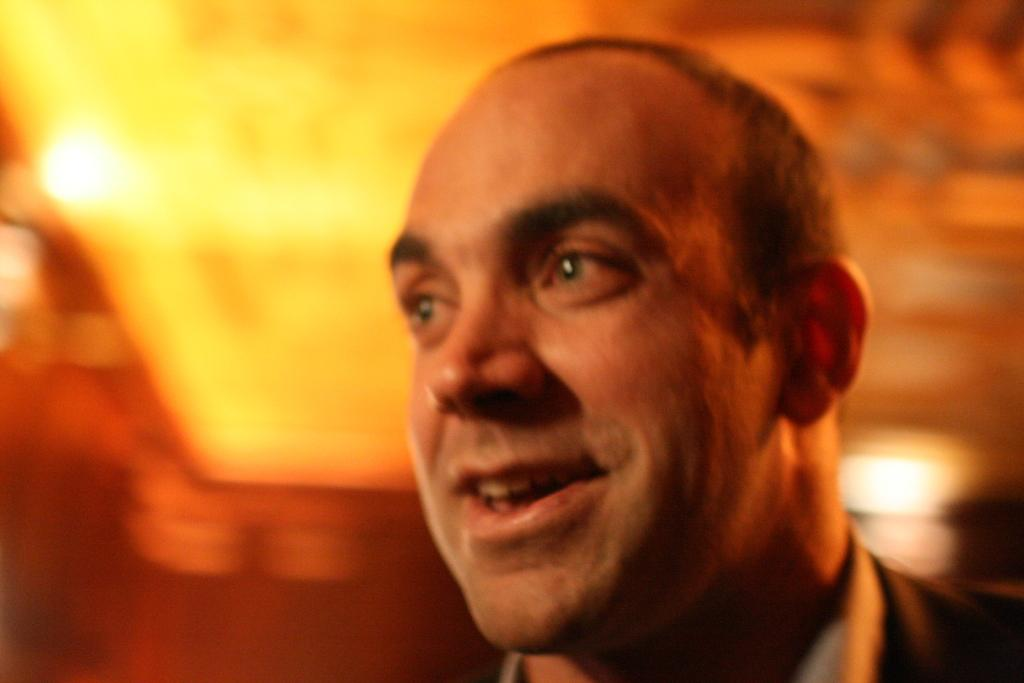Who is the main subject in the image? There is a man in the center of the image. What can be seen in the background of the image? There are lights in the background of the image. How would you describe the background area of the image? The background area of the image is blurry. What type of tools does the carpenter have in the image? There is no carpenter or tools present in the image. Is the partner of the man visible in the image? There is no partner mentioned or visible in the image. 